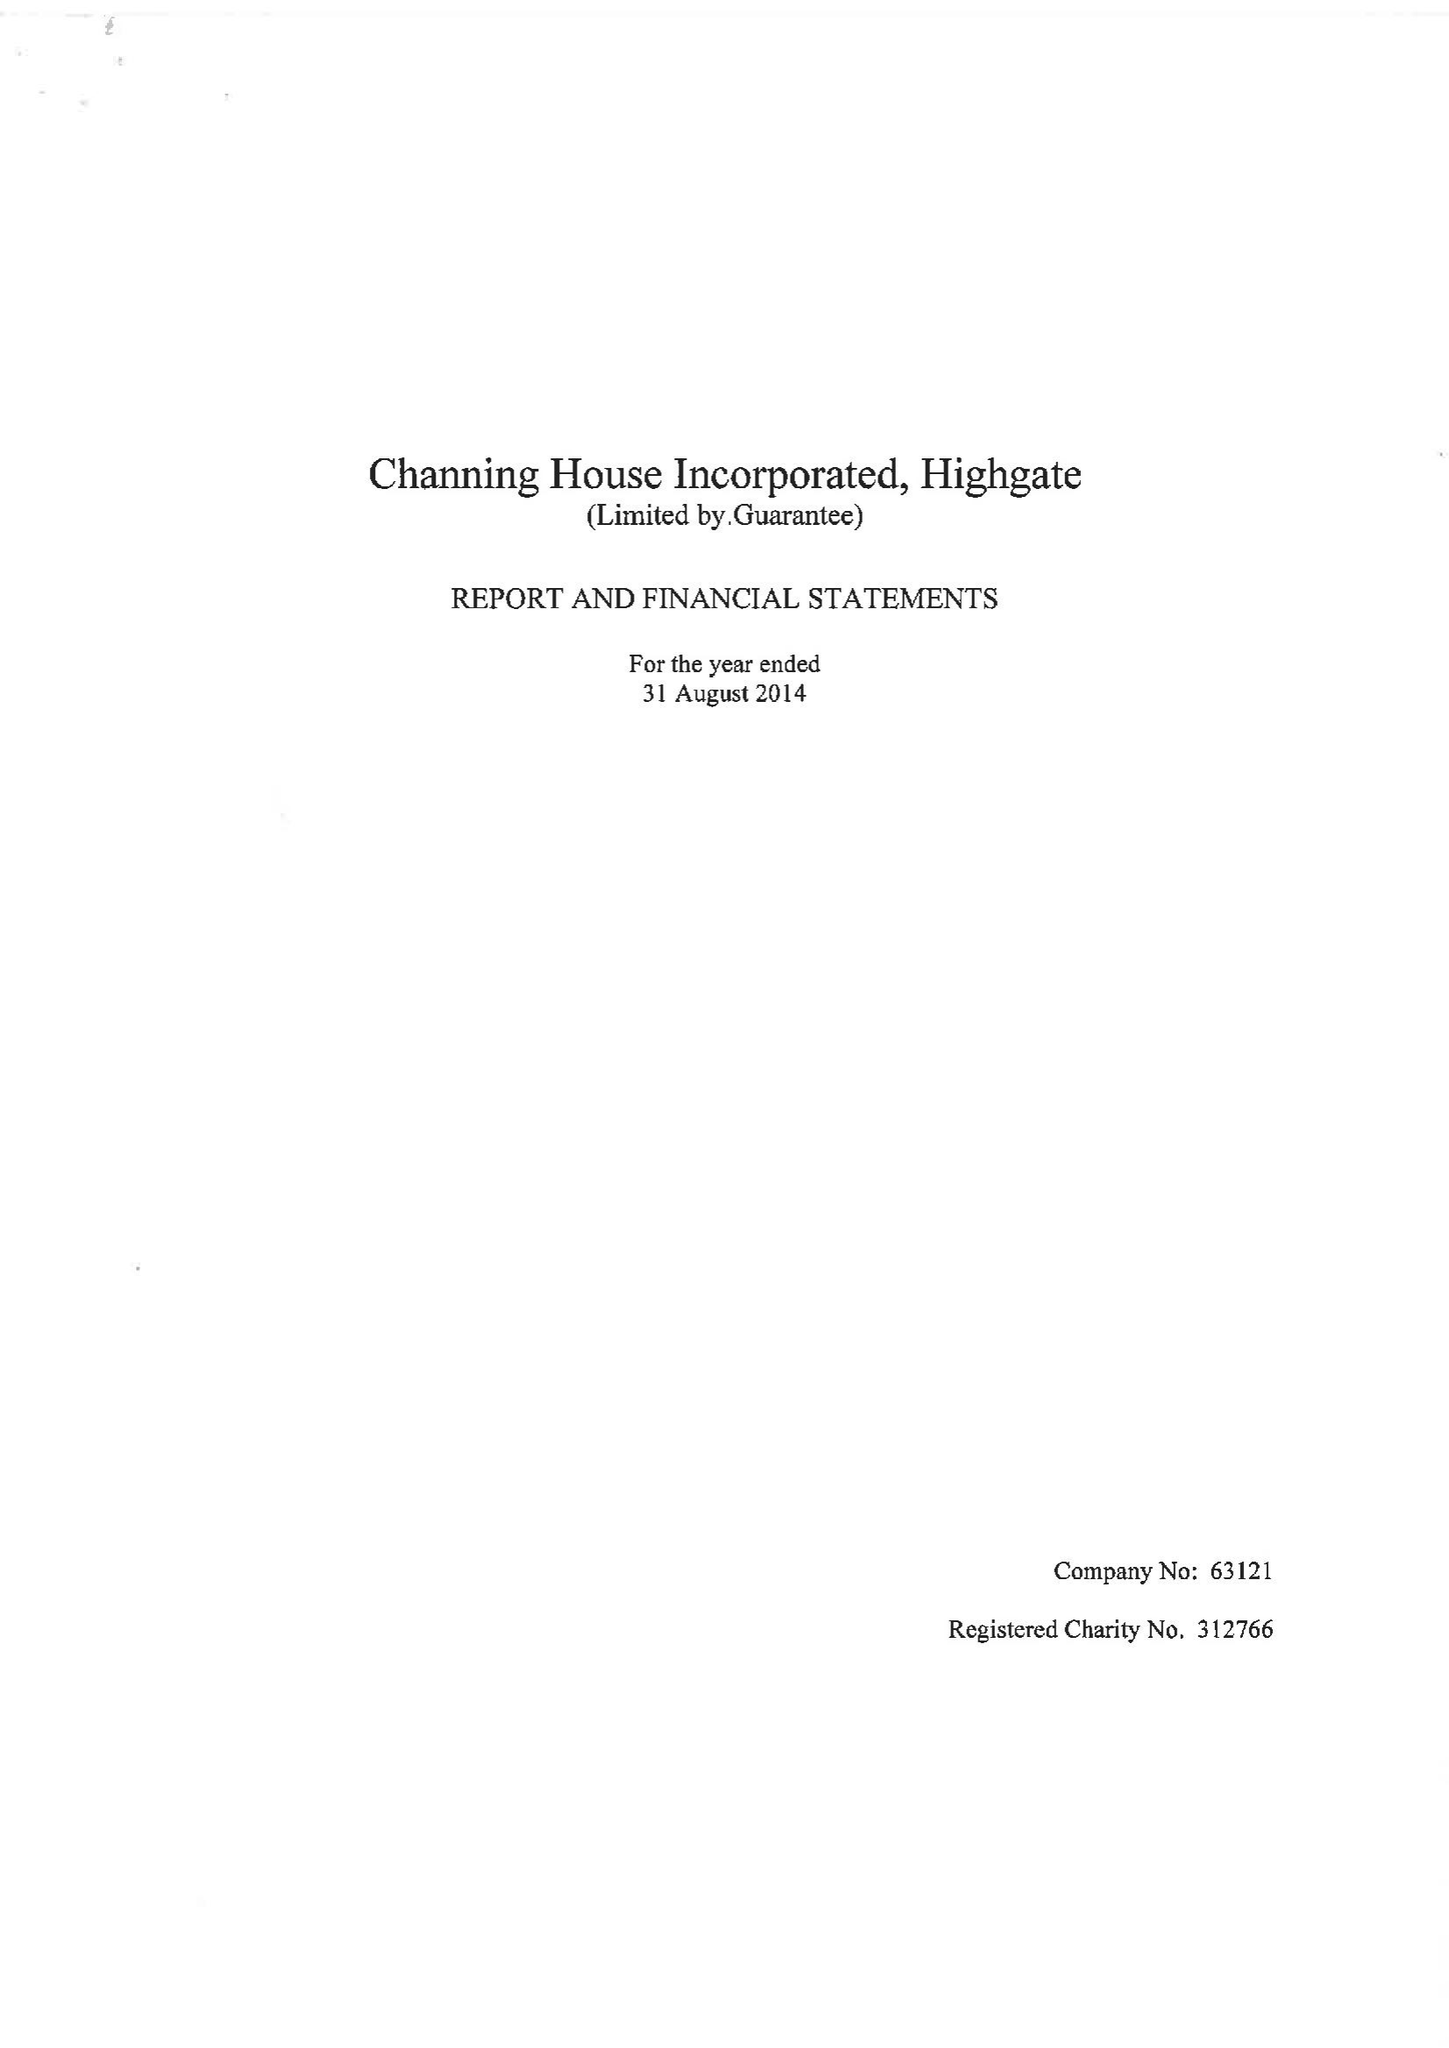What is the value for the report_date?
Answer the question using a single word or phrase. 2014-08-31 